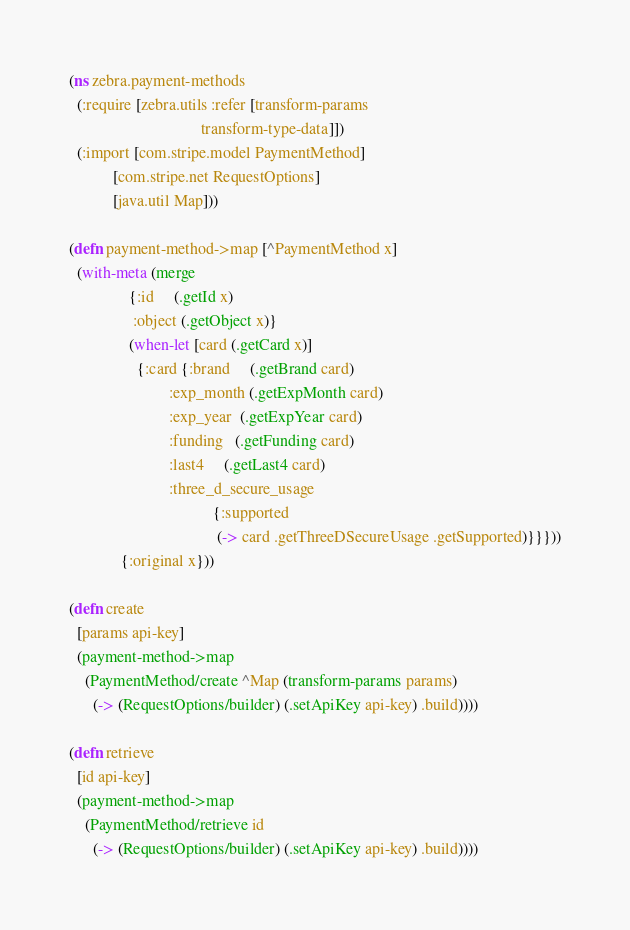<code> <loc_0><loc_0><loc_500><loc_500><_Clojure_>(ns zebra.payment-methods
  (:require [zebra.utils :refer [transform-params
                                 transform-type-data]])
  (:import [com.stripe.model PaymentMethod]
           [com.stripe.net RequestOptions]
           [java.util Map]))

(defn payment-method->map [^PaymentMethod x]
  (with-meta (merge
               {:id     (.getId x)
                :object (.getObject x)}
               (when-let [card (.getCard x)]
                 {:card {:brand     (.getBrand card)
                         :exp_month (.getExpMonth card)
                         :exp_year  (.getExpYear card)
                         :funding   (.getFunding card)
                         :last4     (.getLast4 card)
                         :three_d_secure_usage
                                    {:supported
                                     (-> card .getThreeDSecureUsage .getSupported)}}}))
             {:original x}))

(defn create
  [params api-key]
  (payment-method->map
    (PaymentMethod/create ^Map (transform-params params)
      (-> (RequestOptions/builder) (.setApiKey api-key) .build))))

(defn retrieve
  [id api-key]
  (payment-method->map
    (PaymentMethod/retrieve id
      (-> (RequestOptions/builder) (.setApiKey api-key) .build))))
</code> 